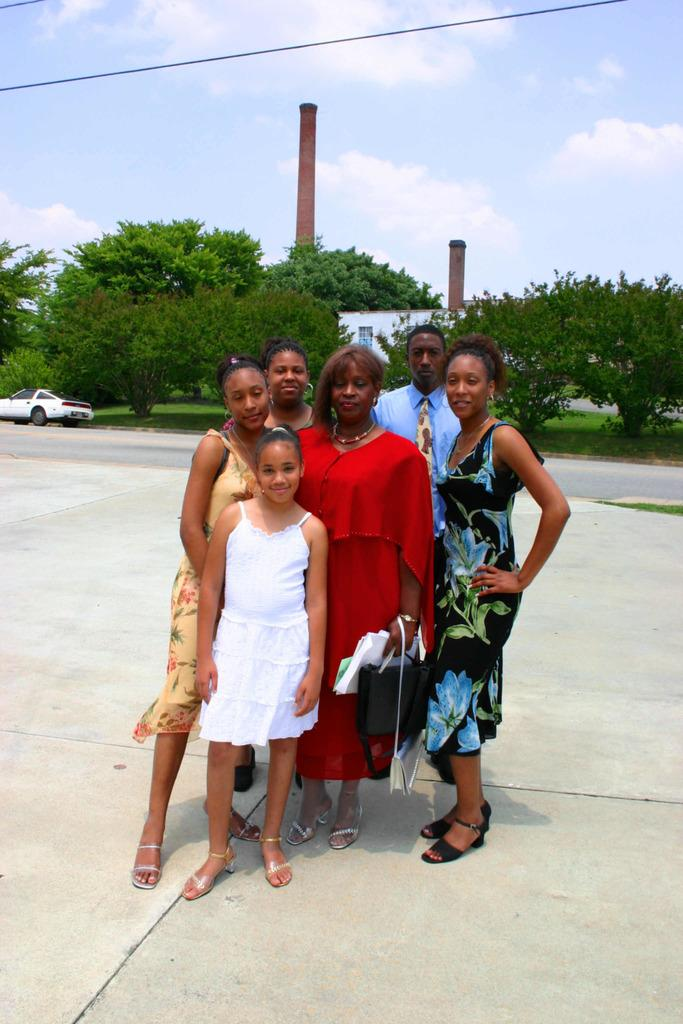What is the main subject of the image? There is a group of people on the ground. What can be seen in the background of the image? There is a vehicle, a house, trees, towers, and the sky visible in the background of the image. Can you describe the setting of the image? The image appears to be set in an area with a mix of natural and man-made structures, including trees, towers, and a house. What type of butter is being used by the people in the image? There is no butter present in the image; it features a group of people on the ground and various background elements. 